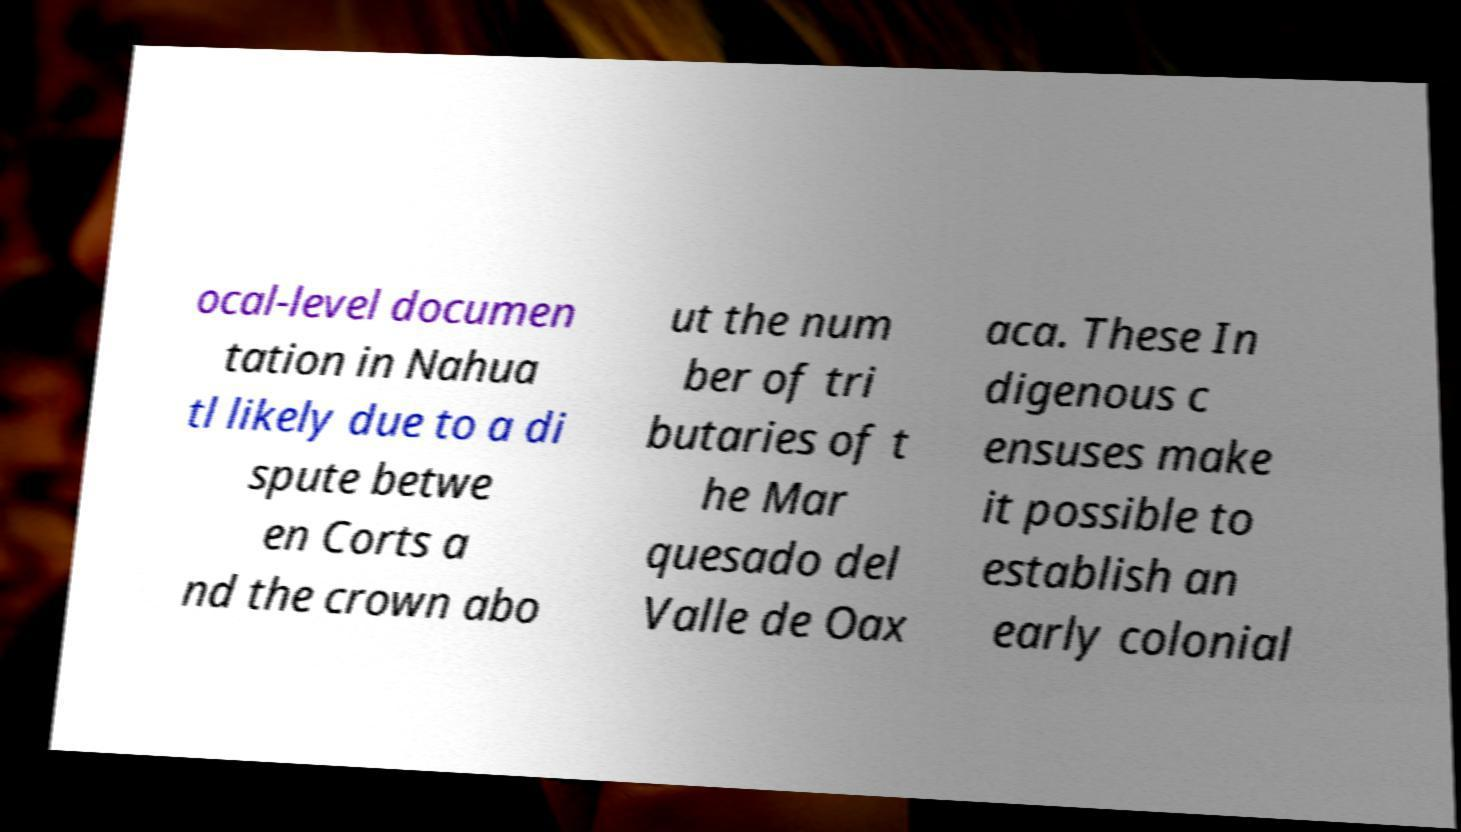Please identify and transcribe the text found in this image. ocal-level documen tation in Nahua tl likely due to a di spute betwe en Corts a nd the crown abo ut the num ber of tri butaries of t he Mar quesado del Valle de Oax aca. These In digenous c ensuses make it possible to establish an early colonial 